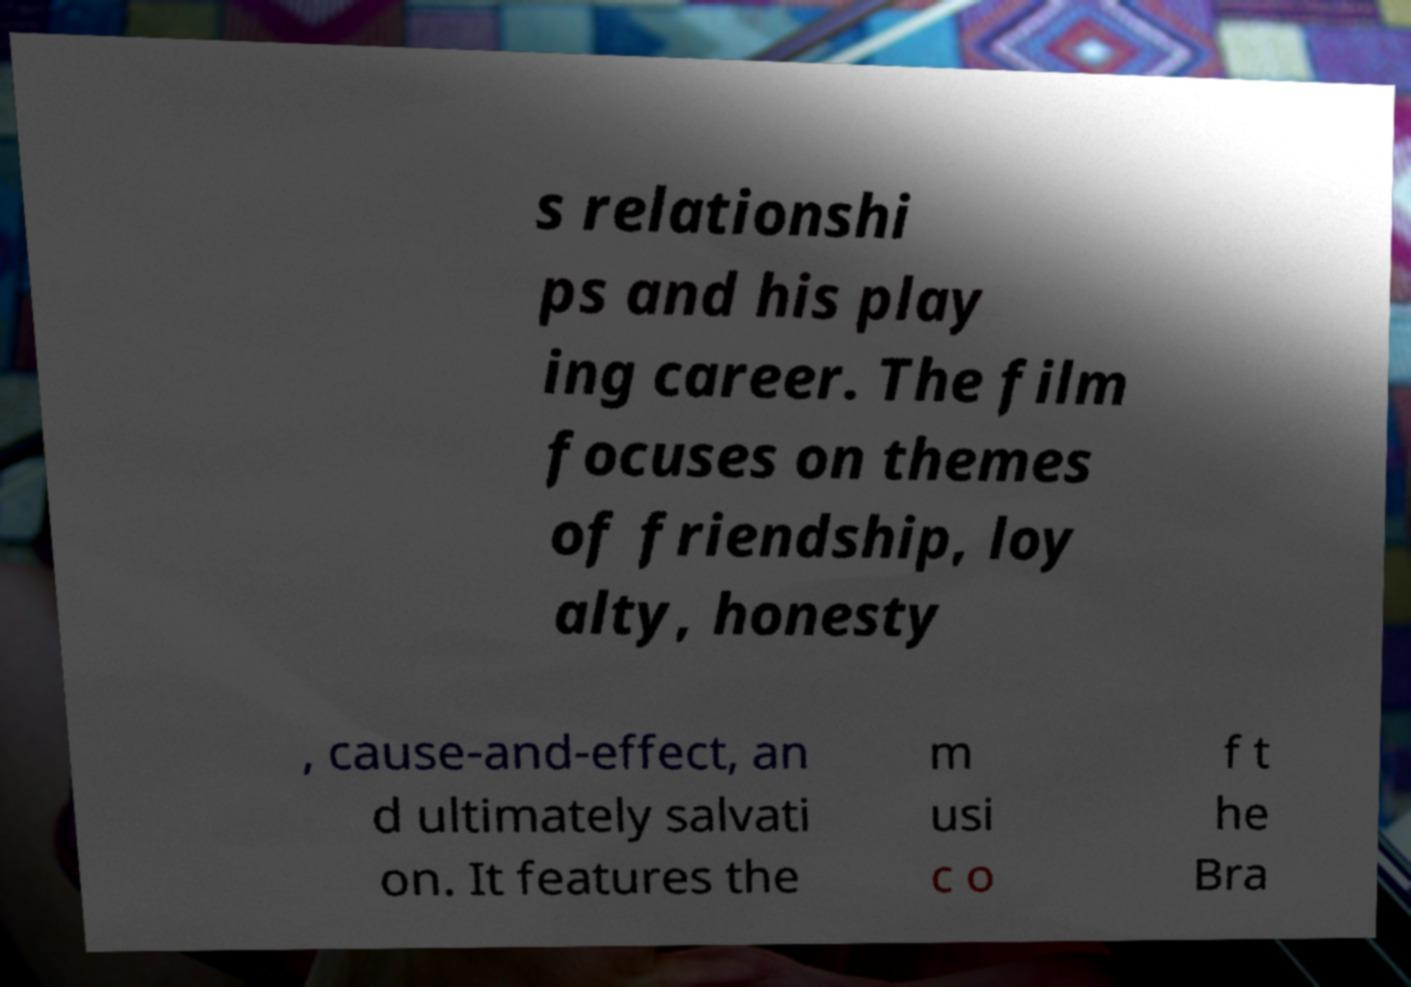There's text embedded in this image that I need extracted. Can you transcribe it verbatim? s relationshi ps and his play ing career. The film focuses on themes of friendship, loy alty, honesty , cause-and-effect, an d ultimately salvati on. It features the m usi c o f t he Bra 